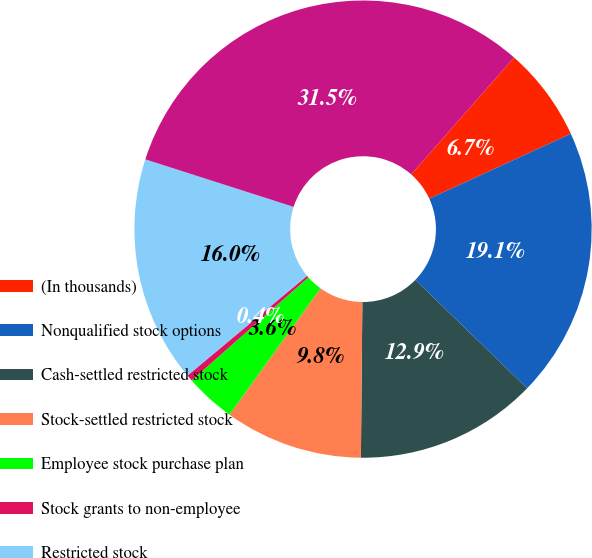Convert chart. <chart><loc_0><loc_0><loc_500><loc_500><pie_chart><fcel>(In thousands)<fcel>Nonqualified stock options<fcel>Cash-settled restricted stock<fcel>Stock-settled restricted stock<fcel>Employee stock purchase plan<fcel>Stock grants to non-employee<fcel>Restricted stock<fcel>Share-based compensation<nl><fcel>6.67%<fcel>19.11%<fcel>12.89%<fcel>9.78%<fcel>3.56%<fcel>0.45%<fcel>16.0%<fcel>31.55%<nl></chart> 